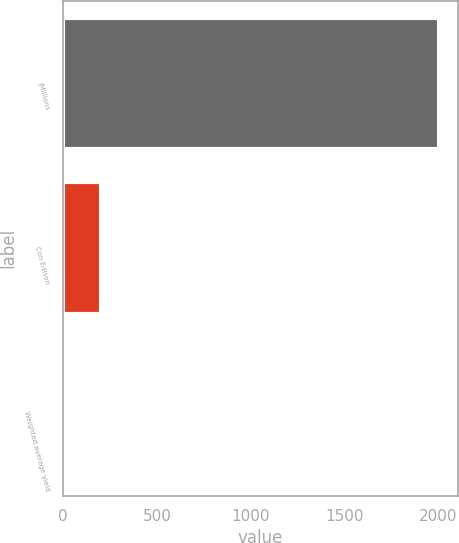Convert chart. <chart><loc_0><loc_0><loc_500><loc_500><bar_chart><fcel>(Millions<fcel>Con Edison<fcel>Weighted average yield<nl><fcel>2002<fcel>201.28<fcel>1.2<nl></chart> 